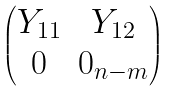<formula> <loc_0><loc_0><loc_500><loc_500>\begin{pmatrix} Y _ { 1 1 } & Y _ { 1 2 } \\ 0 & 0 _ { n - m } \end{pmatrix}</formula> 